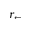Convert formula to latex. <formula><loc_0><loc_0><loc_500><loc_500>r _ { \leftarrow }</formula> 